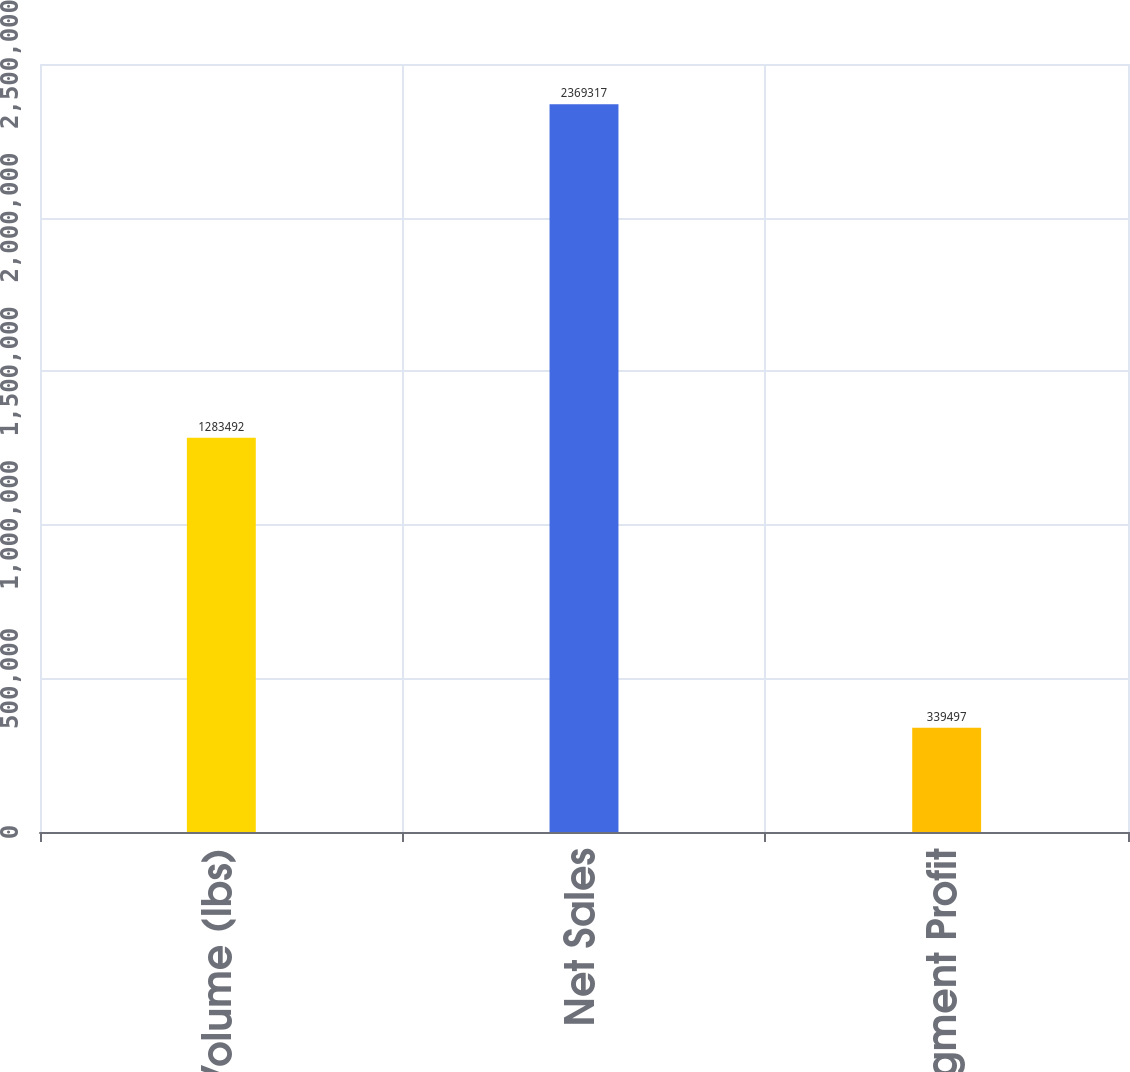Convert chart to OTSL. <chart><loc_0><loc_0><loc_500><loc_500><bar_chart><fcel>Volume (lbs)<fcel>Net Sales<fcel>Segment Profit<nl><fcel>1.28349e+06<fcel>2.36932e+06<fcel>339497<nl></chart> 